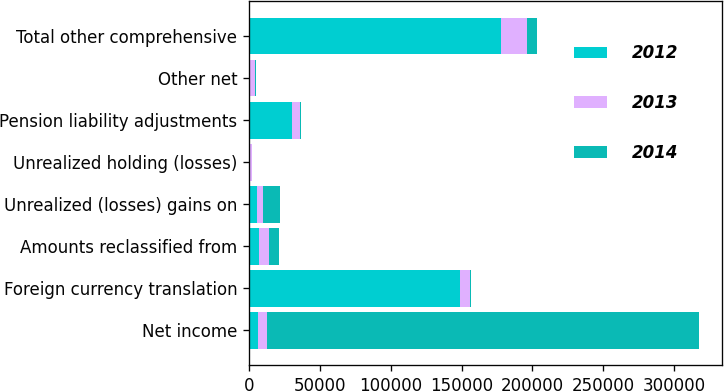<chart> <loc_0><loc_0><loc_500><loc_500><stacked_bar_chart><ecel><fcel>Net income<fcel>Foreign currency translation<fcel>Amounts reclassified from<fcel>Unrealized (losses) gains on<fcel>Unrealized holding (losses)<fcel>Pension liability adjustments<fcel>Other net<fcel>Total other comprehensive<nl><fcel>2012<fcel>6452<fcel>148589<fcel>7279<fcel>5927<fcel>941<fcel>30355<fcel>549<fcel>177984<nl><fcel>2013<fcel>6452<fcel>7390<fcel>7151<fcel>4361<fcel>1151<fcel>5638<fcel>3720<fcel>18135<nl><fcel>2014<fcel>304787<fcel>997<fcel>6977<fcel>11901<fcel>475<fcel>947<fcel>598<fcel>6991<nl></chart> 